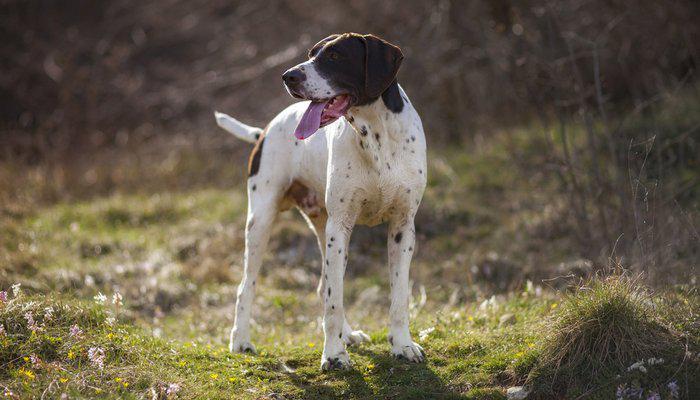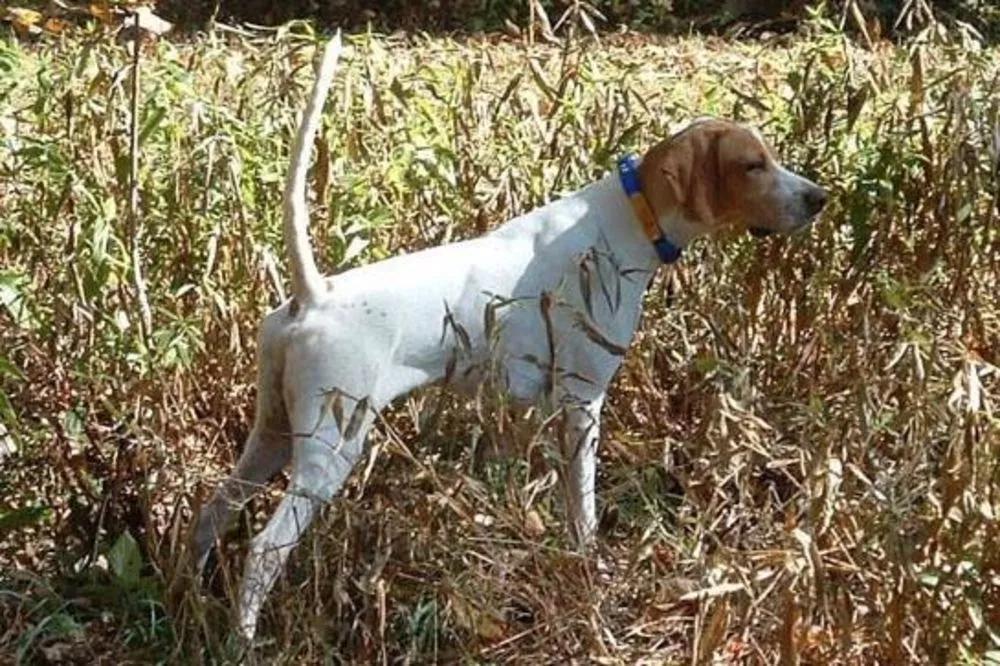The first image is the image on the left, the second image is the image on the right. Considering the images on both sides, is "There is the same number of dogs in both images." valid? Answer yes or no. Yes. The first image is the image on the left, the second image is the image on the right. For the images shown, is this caption "Each image includes one hound in a standing position, and the dog on the left is black-and-white with an open mouth and tail sticking out." true? Answer yes or no. Yes. 